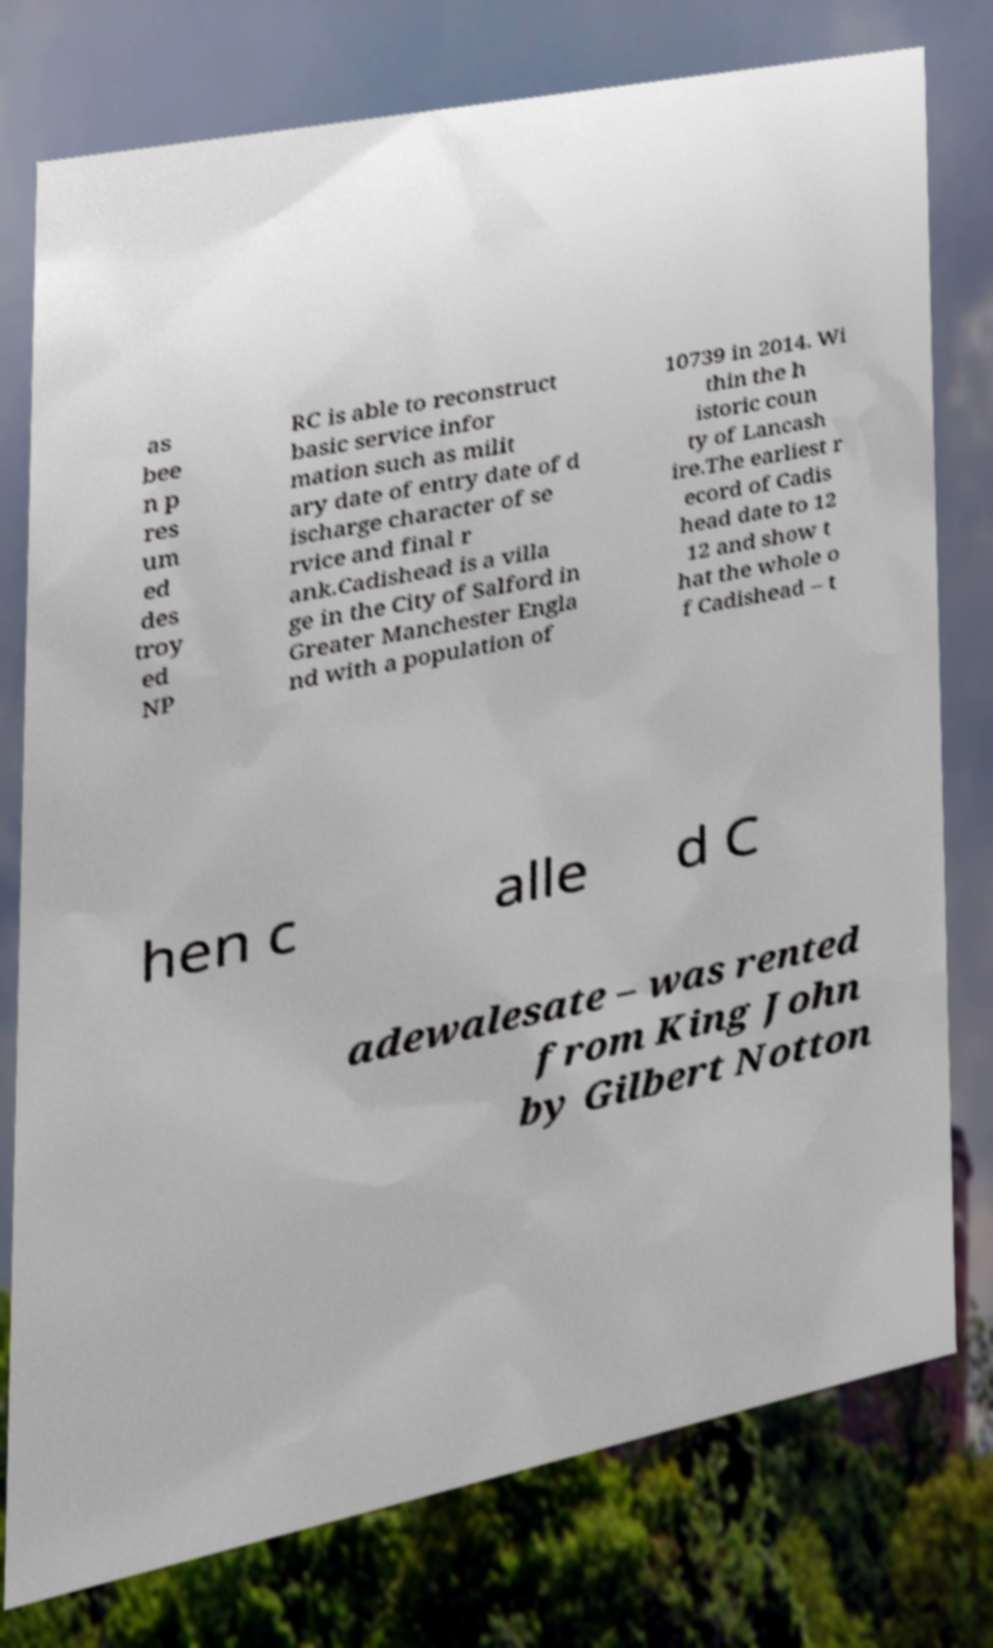Please identify and transcribe the text found in this image. as bee n p res um ed des troy ed NP RC is able to reconstruct basic service infor mation such as milit ary date of entry date of d ischarge character of se rvice and final r ank.Cadishead is a villa ge in the City of Salford in Greater Manchester Engla nd with a population of 10739 in 2014. Wi thin the h istoric coun ty of Lancash ire.The earliest r ecord of Cadis head date to 12 12 and show t hat the whole o f Cadishead – t hen c alle d C adewalesate – was rented from King John by Gilbert Notton 